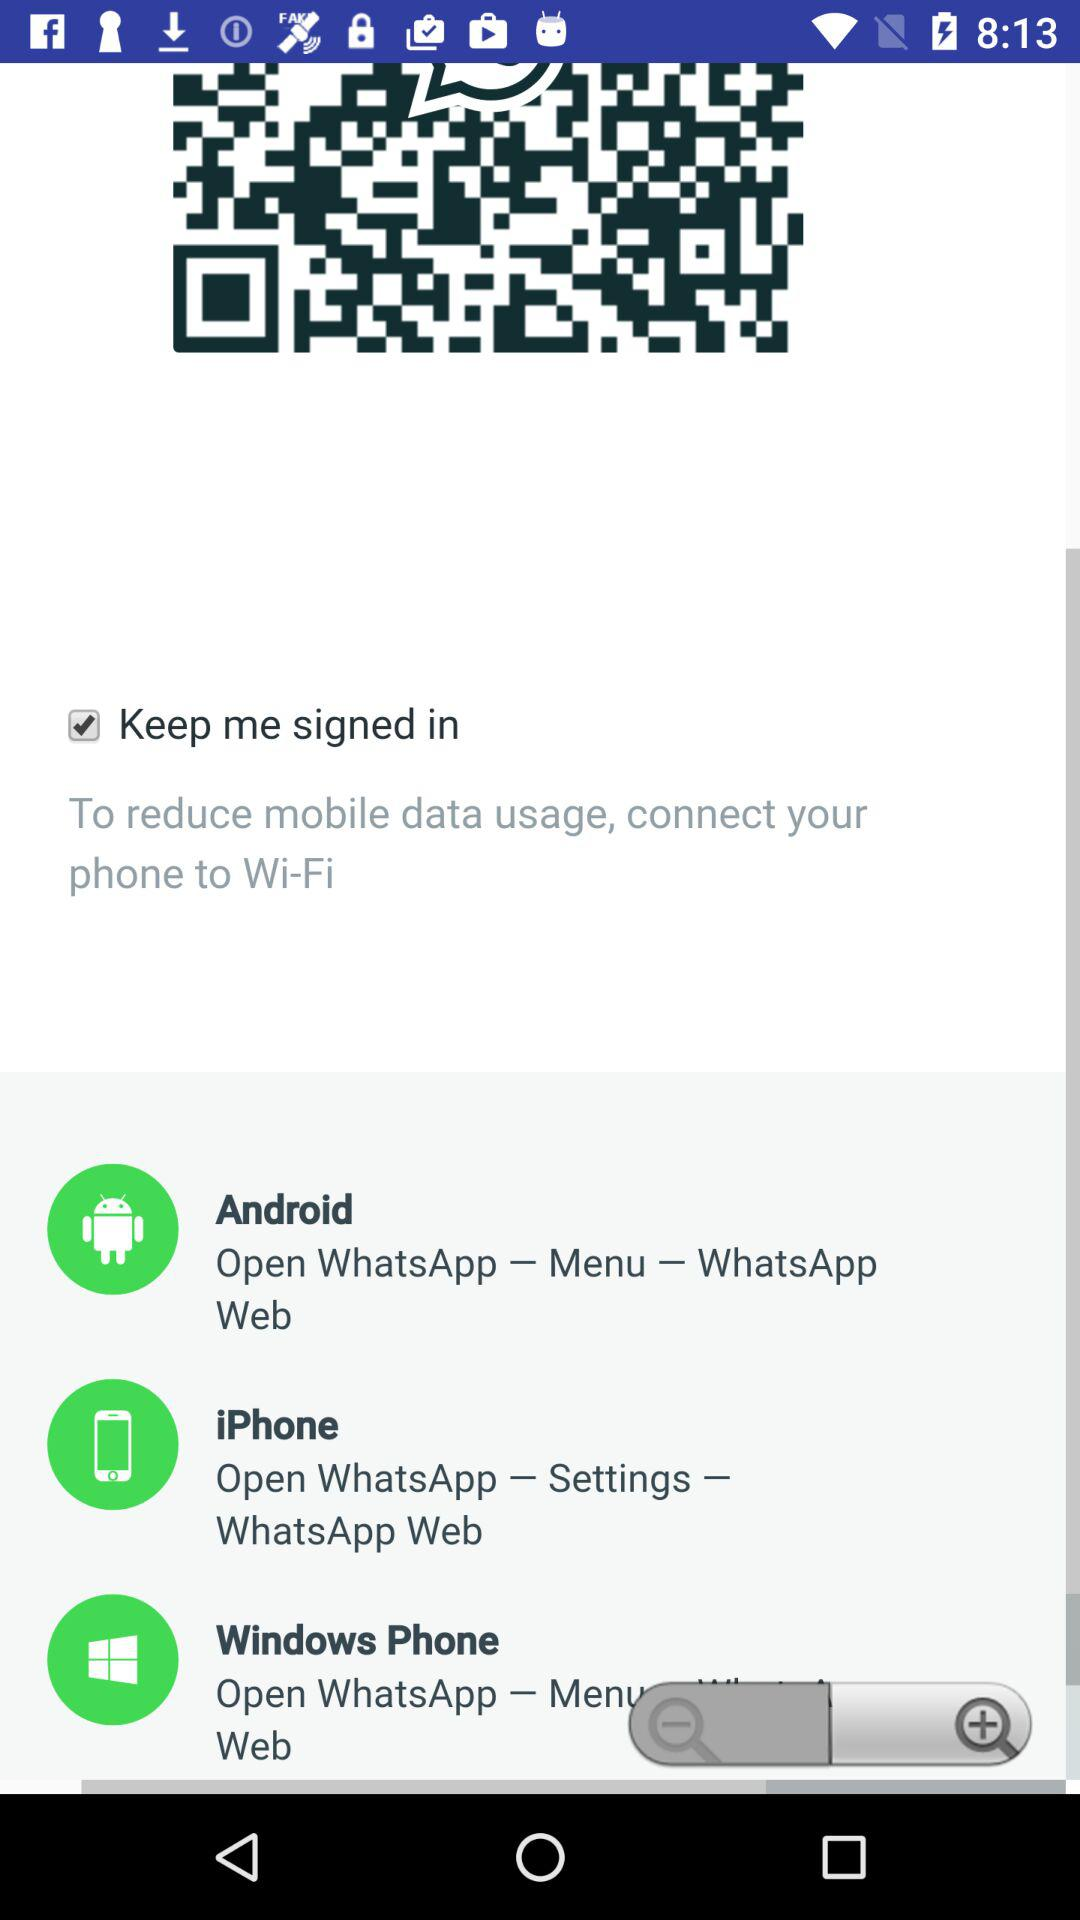Is "Keep me signed in" checked or not? "Keep me signed in" is checked. 